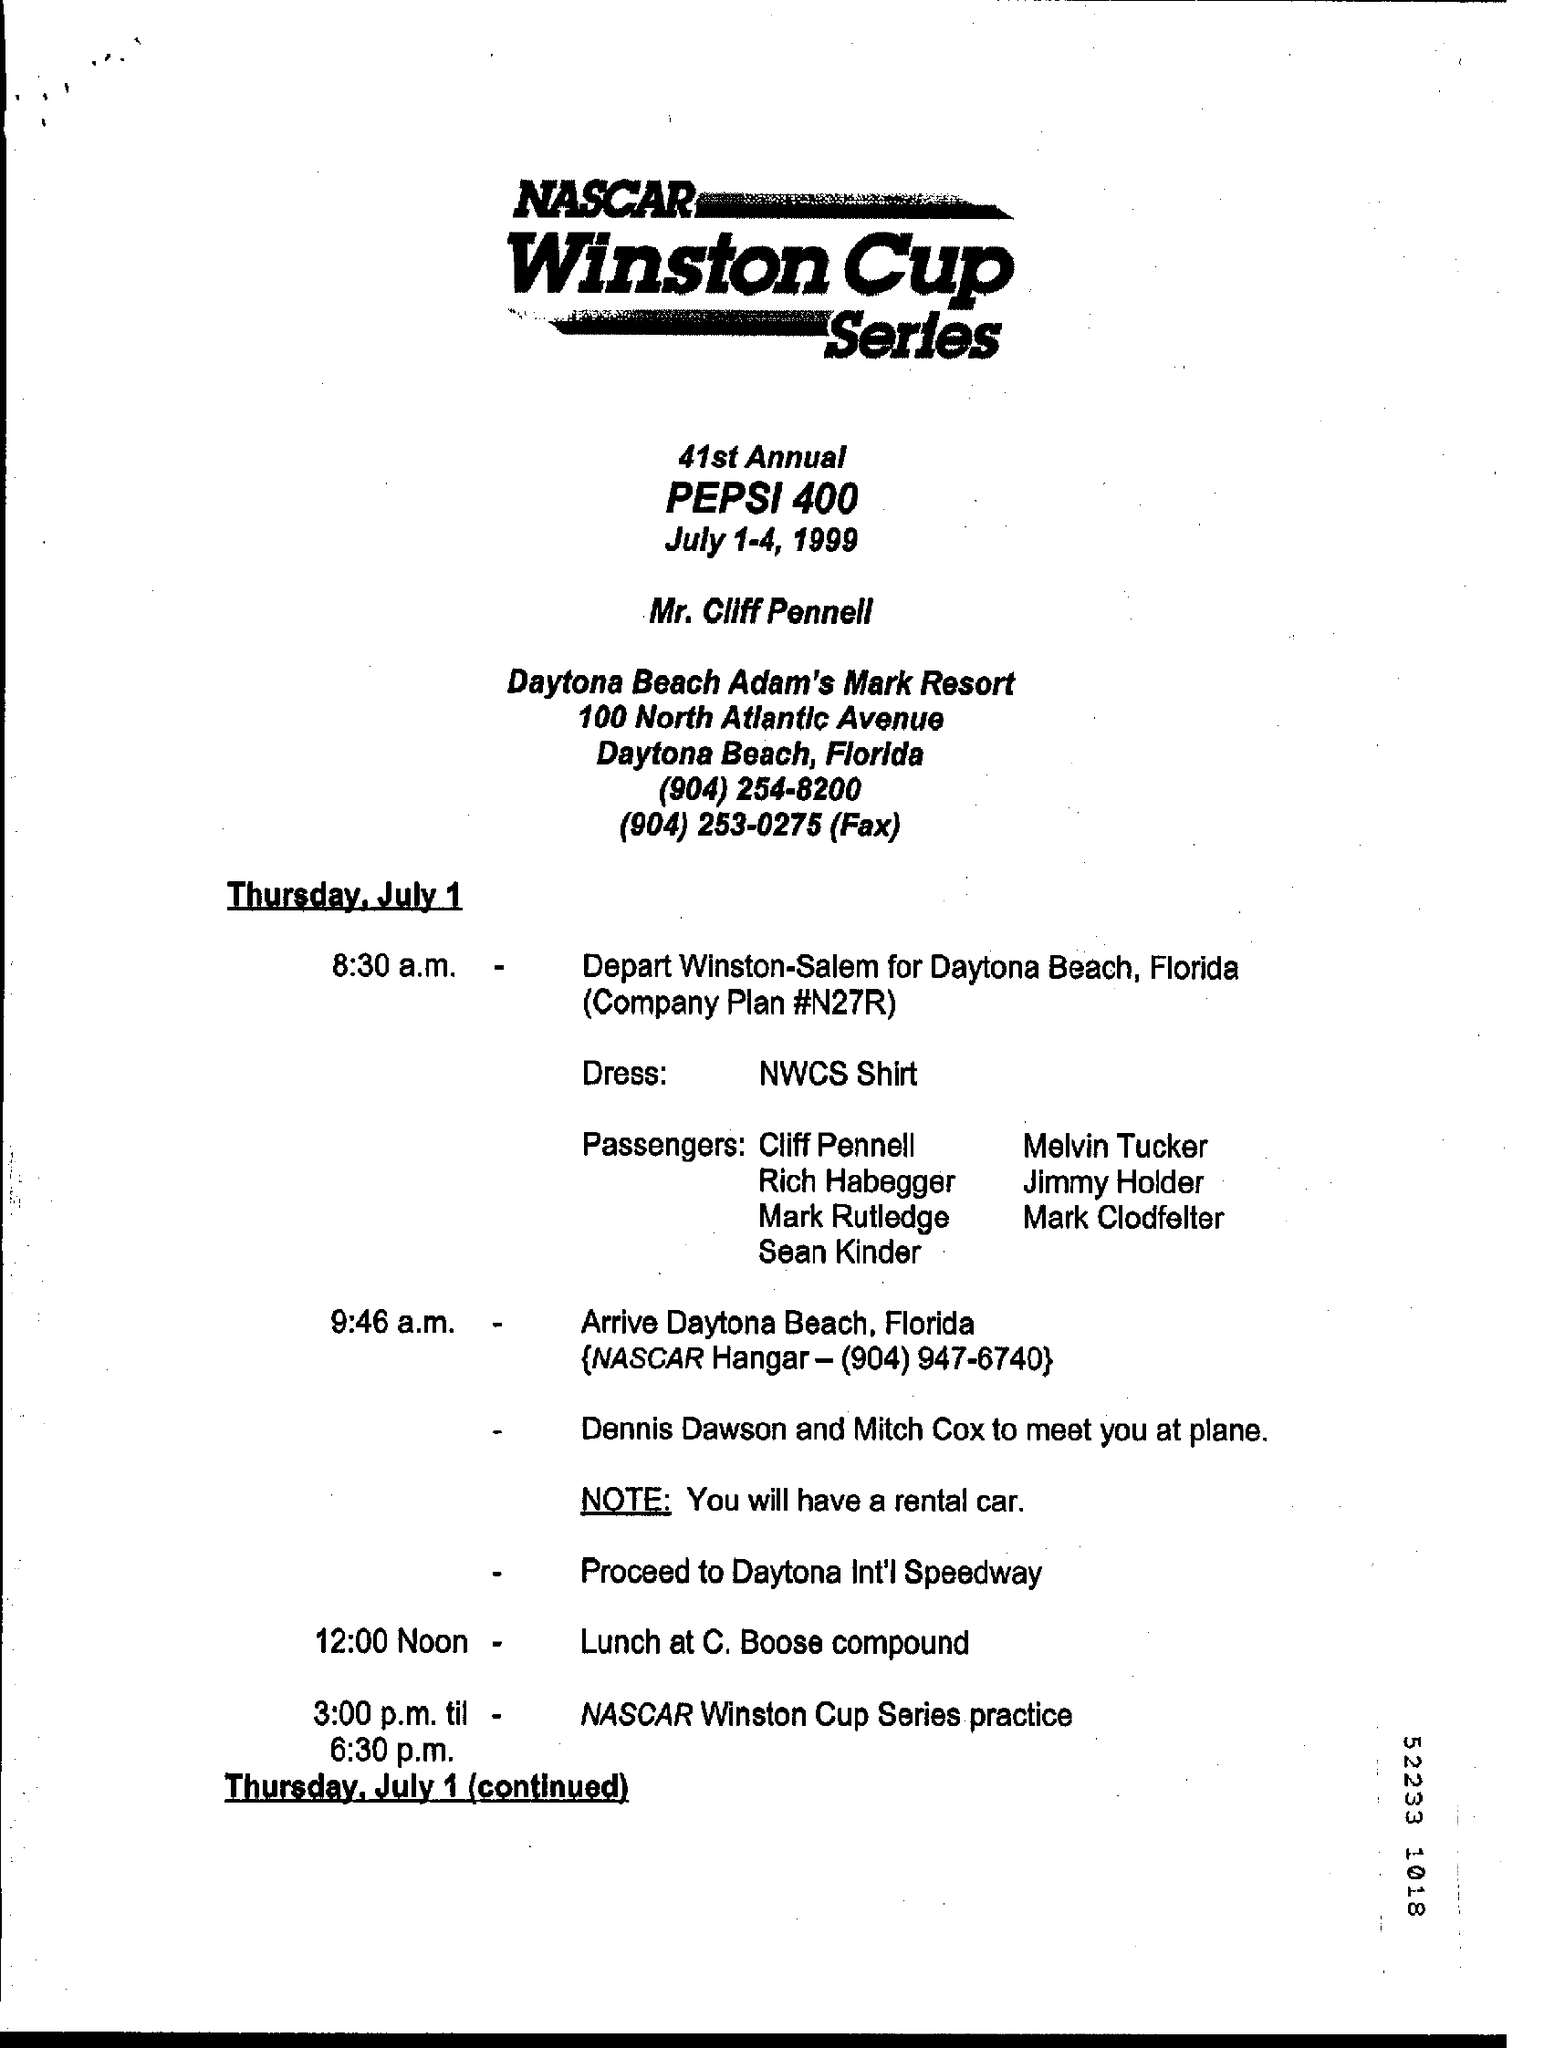When is the 41st annual pepsi 400 held?
Offer a terse response. July 1-4, 1999. What is dress code?
Make the answer very short. NWCS Shirt. 